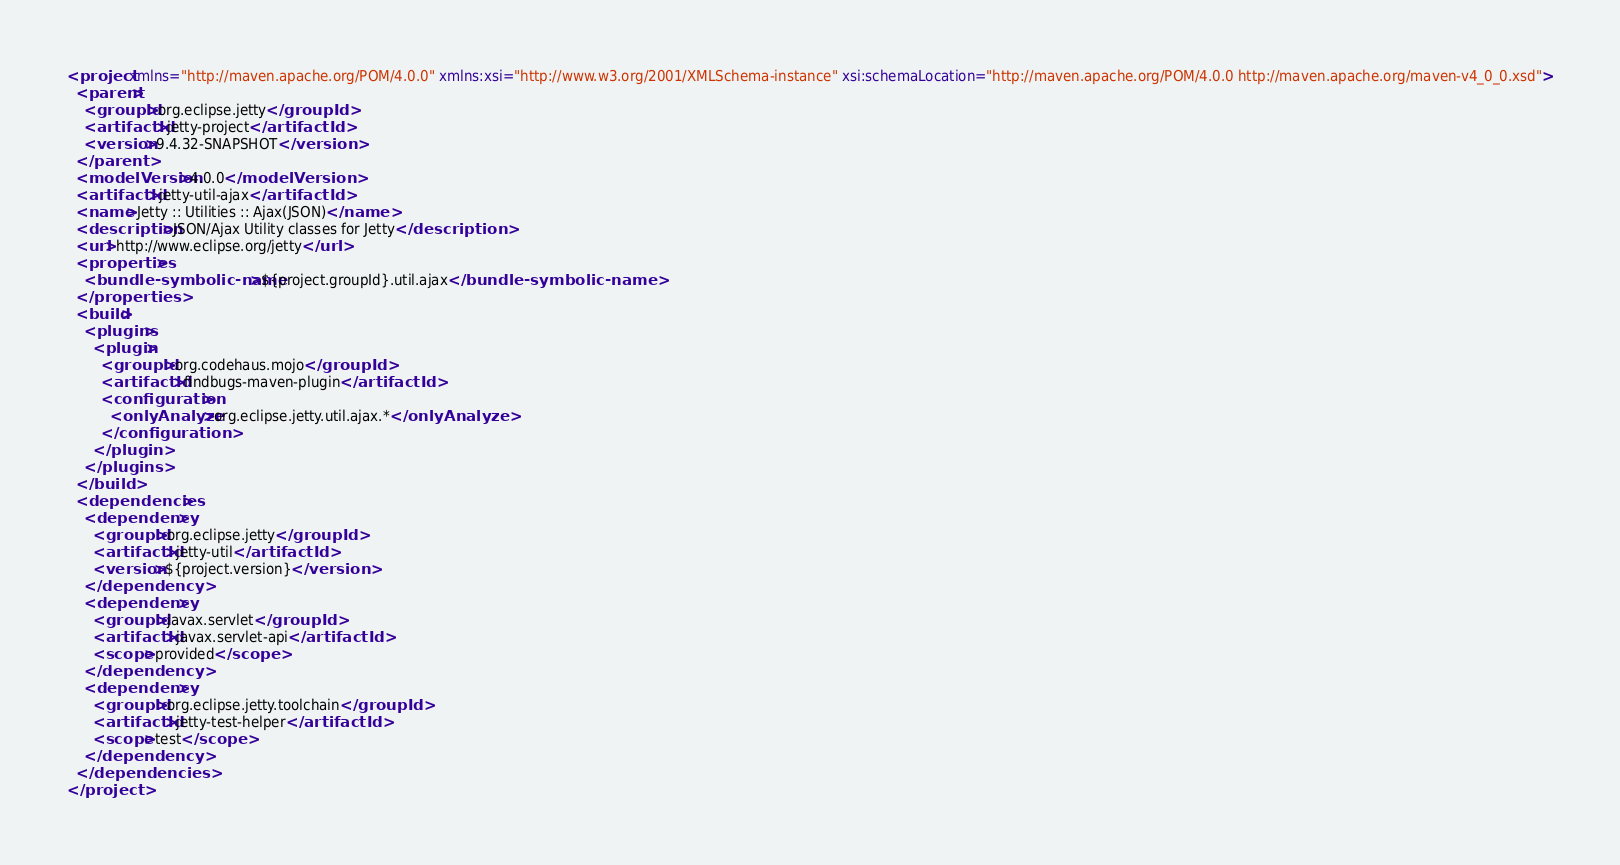Convert code to text. <code><loc_0><loc_0><loc_500><loc_500><_XML_><project xmlns="http://maven.apache.org/POM/4.0.0" xmlns:xsi="http://www.w3.org/2001/XMLSchema-instance" xsi:schemaLocation="http://maven.apache.org/POM/4.0.0 http://maven.apache.org/maven-v4_0_0.xsd">
  <parent>
    <groupId>org.eclipse.jetty</groupId>
    <artifactId>jetty-project</artifactId>
    <version>9.4.32-SNAPSHOT</version>
  </parent>
  <modelVersion>4.0.0</modelVersion>
  <artifactId>jetty-util-ajax</artifactId>
  <name>Jetty :: Utilities :: Ajax(JSON)</name>
  <description>JSON/Ajax Utility classes for Jetty</description>
  <url>http://www.eclipse.org/jetty</url>
  <properties>
    <bundle-symbolic-name>${project.groupId}.util.ajax</bundle-symbolic-name>
  </properties>
  <build>
    <plugins>
      <plugin>
        <groupId>org.codehaus.mojo</groupId>
        <artifactId>findbugs-maven-plugin</artifactId>
        <configuration>
          <onlyAnalyze>org.eclipse.jetty.util.ajax.*</onlyAnalyze>
        </configuration>
      </plugin>
    </plugins>
  </build>
  <dependencies>
    <dependency>
      <groupId>org.eclipse.jetty</groupId>
      <artifactId>jetty-util</artifactId>
      <version>${project.version}</version>
    </dependency>
    <dependency>
      <groupId>javax.servlet</groupId>
      <artifactId>javax.servlet-api</artifactId>
      <scope>provided</scope>
    </dependency>
    <dependency>
      <groupId>org.eclipse.jetty.toolchain</groupId>
      <artifactId>jetty-test-helper</artifactId>
      <scope>test</scope>
    </dependency>
  </dependencies>
</project>
</code> 